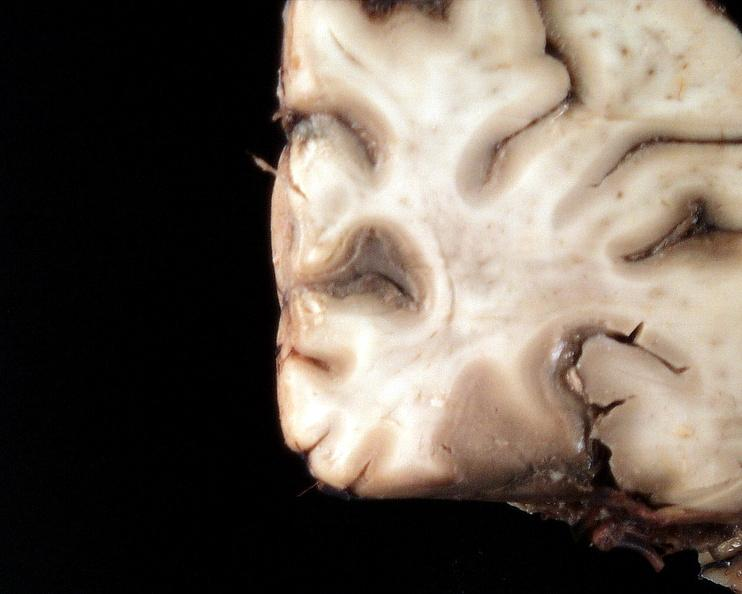what is present?
Answer the question using a single word or phrase. Nervous 